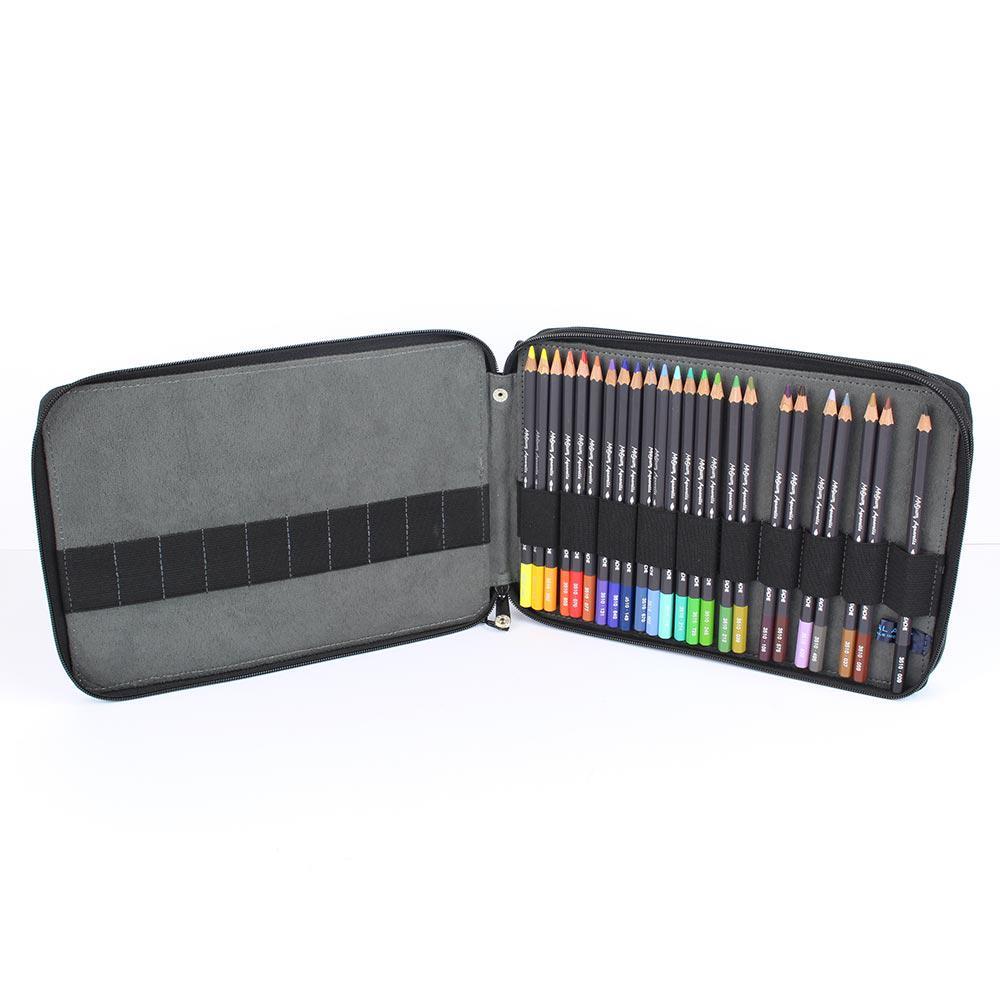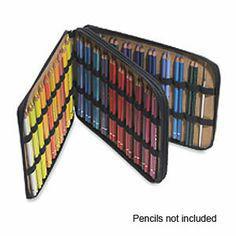The first image is the image on the left, the second image is the image on the right. Considering the images on both sides, is "The cases in both images are currently storing only colored pencils." valid? Answer yes or no. Yes. 